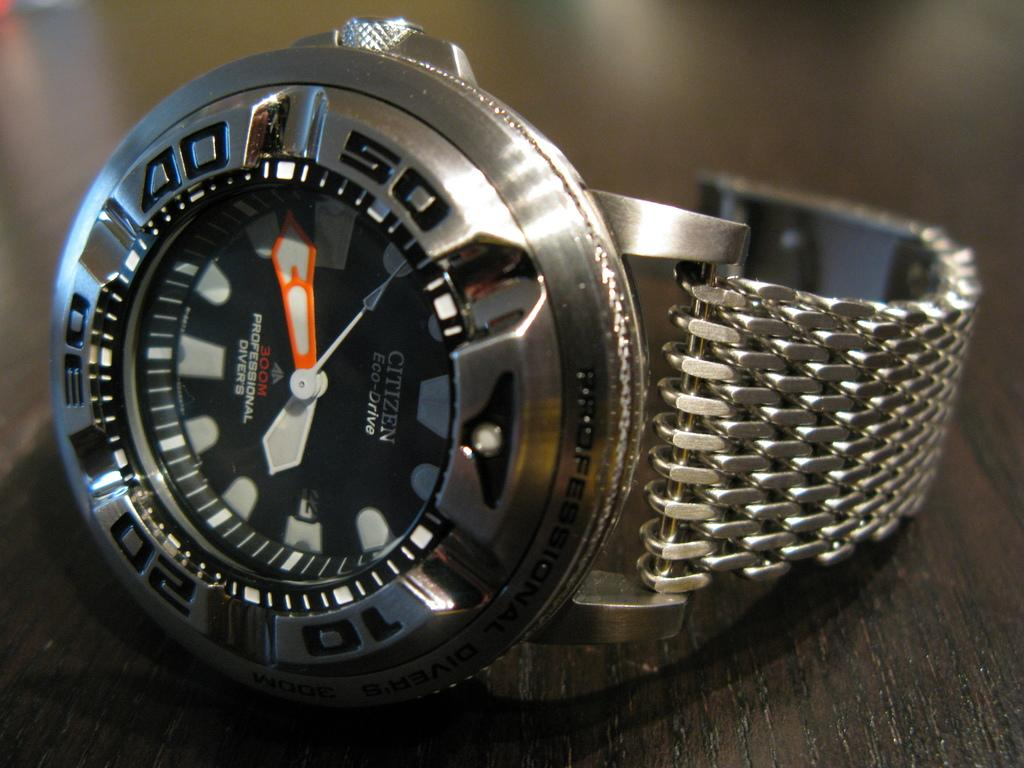Provide a one-sentence caption for the provided image. The Citizen Eco-Drive wrist watch says that the time is about 17 minutes before 4 o'clock. 